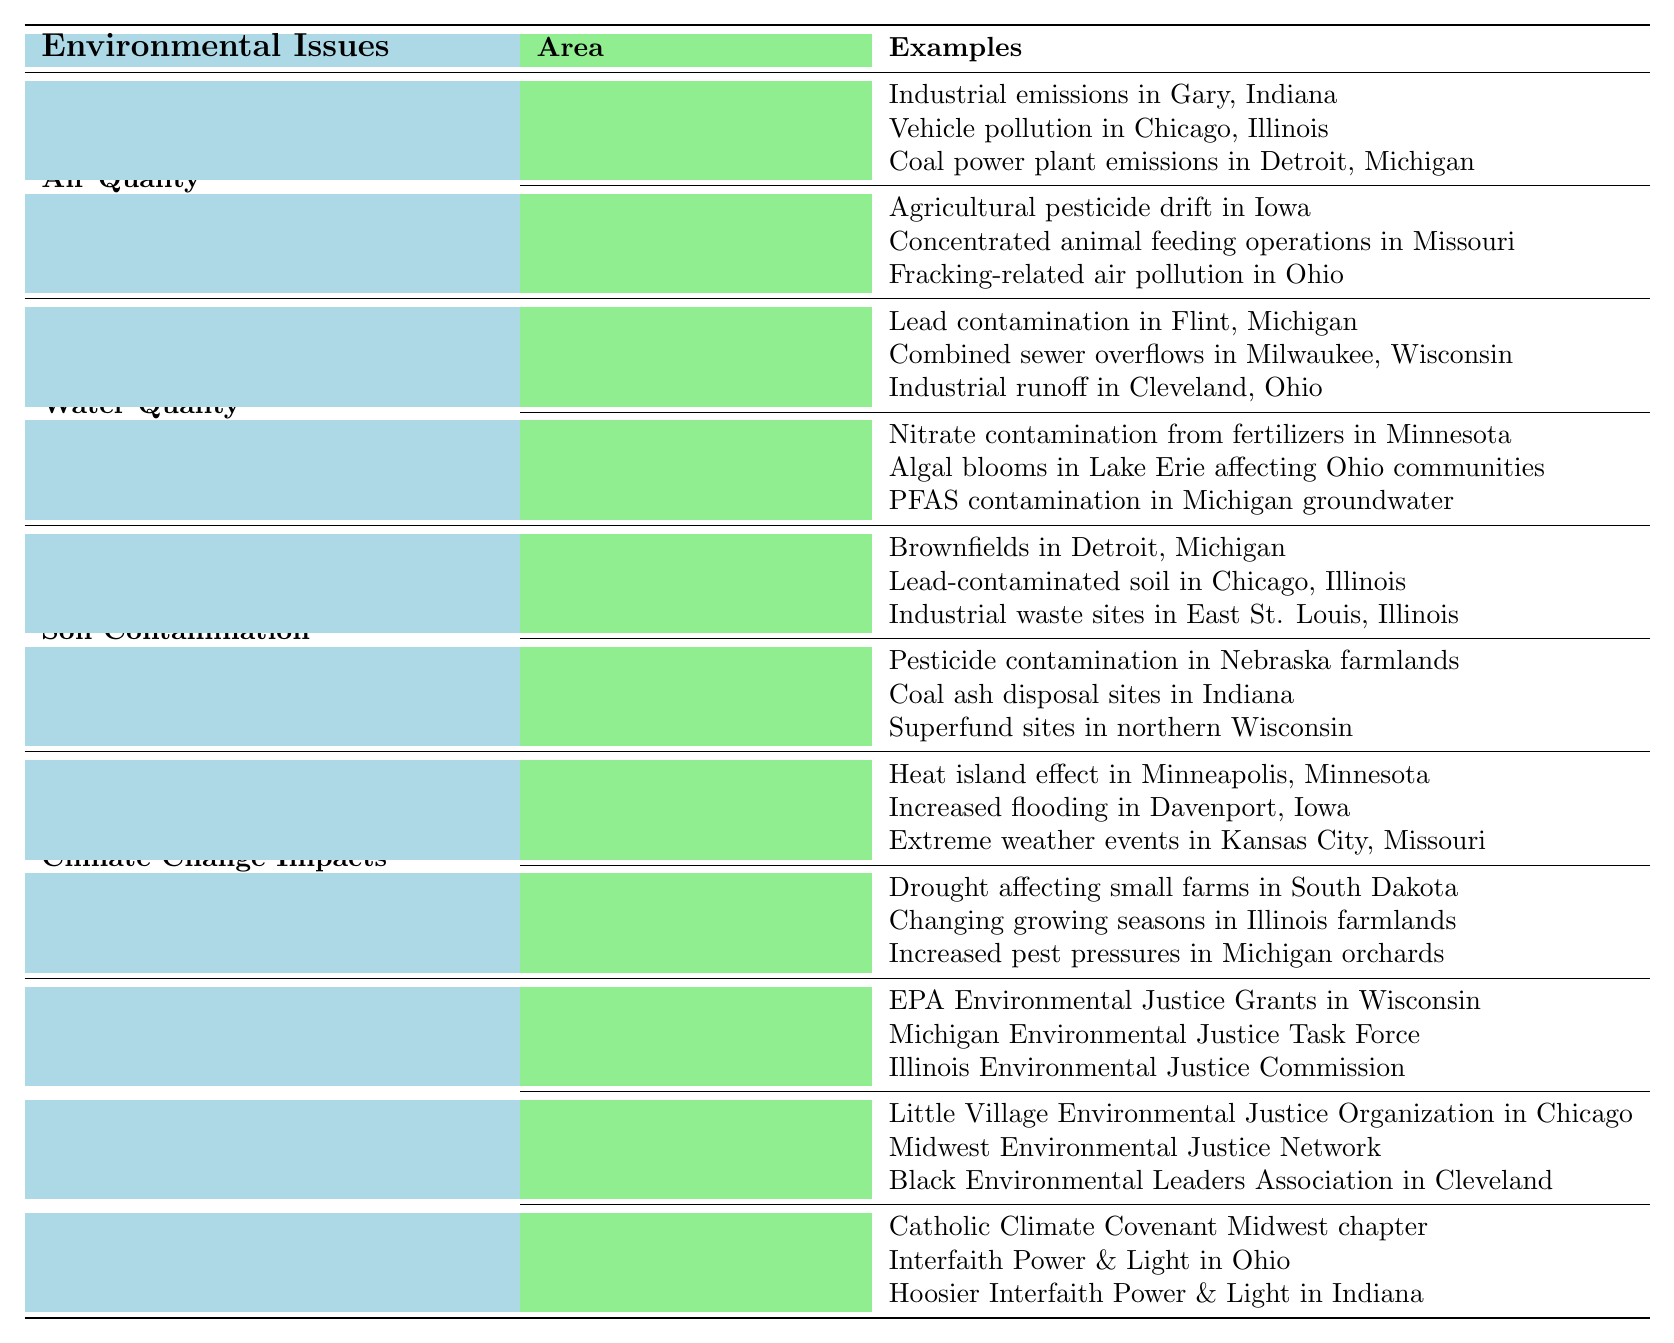What are the examples of air quality issues in urban areas? The table lists specific examples under the "Air Quality" and "Urban Areas" categories. These are: industrial emissions in Gary, Indiana; vehicle pollution in Chicago, Illinois; and coal power plant emissions in Detroit, Michigan.
Answer: Industrial emissions in Gary, Indiana; vehicle pollution in Chicago, Illinois; coal power plant emissions in Detroit, Michigan How many examples are there for water quality issues in rural areas? In the "Water Quality" section under "Rural Issues," there are three specific examples listed: nitrate contamination from fertilizers in Minnesota, algal blooms in Lake Erie affecting Ohio communities, and PFAS contamination in Michigan groundwater. Therefore, the count is three.
Answer: Three Is there a mention of lead contamination affecting urban areas? The table includes lead contamination in Flint, Michigan, which is categorized under "Water Quality" and "Urban Issues." Thus, the statement is true.
Answer: Yes What is the difference in the number of examples provided for urban effects versus rural effects regarding climate change impacts? The table lists three examples under "Urban Effects" and three examples under "Rural Effects" for climate change impacts, making the difference 0, as they have the same count.
Answer: 0 Which environmental justice initiative mentions a faith-based organization? Among the listed "Environmental Justice Initiatives," the examples of faith-based organizations include the Catholic Climate Covenant Midwest chapter, Interfaith Power & Light in Ohio, and Hoosier Interfaith Power & Light in Indiana, confirming the presence of faith-based initiatives.
Answer: Yes Can you identify a specific example of soil contamination in urban sites? The table specifies several examples in the "Soil Contamination" under "Urban Sites." These include brownfields in Detroit, lead-contaminated soil in Chicago, and industrial waste sites in East St. Louis, Illinois.
Answer: Brownfields in Detroit, lead-contaminated soil in Chicago, industrial waste sites in East St. Louis What are the total numbers of examples listed for government programs within environmental justice initiatives? The "Environmental Justice Initiatives" section has three examples listed under "Government Programs": EPA Environmental Justice Grants in Wisconsin, Michigan Environmental Justice Task Force, and Illinois Environmental Justice Commission, giving a total of three.
Answer: Three Is there an example of agricultural pesticide issues found in urban areas? The table does not list any examples of agricultural pesticides under the "Urban Areas" category for environmental issues, indicating that this type of issue is not present in urban contexts as per the table.
Answer: No What environmental issue has the most examples overall in the table? The categories "Air Quality," "Water Quality," "Soil Contamination," and "Climate Change Impacts" each have a total of six examples (3 each for urban and rural/urban issues). However, the "Environmental Justice Initiatives" category has an extended list (9 examples with 3 in each subcategory), making it the one with the most examples overall.
Answer: Environmental Justice Initiatives 